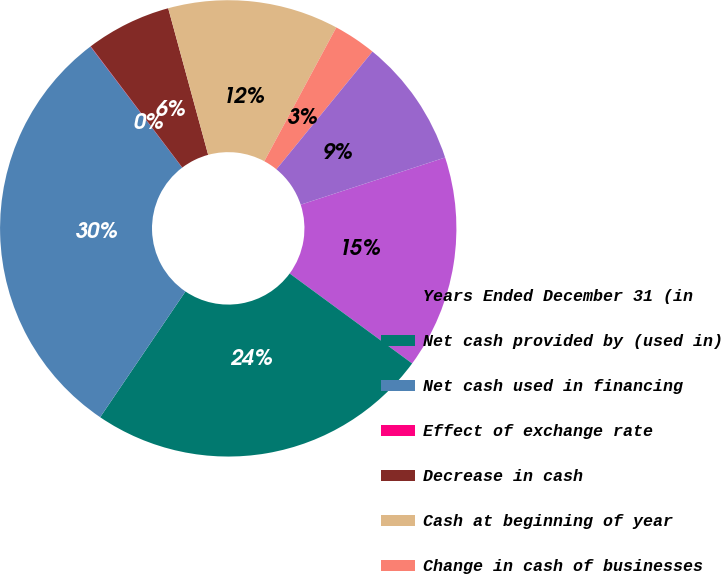Convert chart. <chart><loc_0><loc_0><loc_500><loc_500><pie_chart><fcel>Years Ended December 31 (in<fcel>Net cash provided by (used in)<fcel>Net cash used in financing<fcel>Effect of exchange rate<fcel>Decrease in cash<fcel>Cash at beginning of year<fcel>Change in cash of businesses<fcel>Cash at end of year<nl><fcel>15.11%<fcel>24.4%<fcel>30.2%<fcel>0.02%<fcel>6.06%<fcel>12.09%<fcel>3.04%<fcel>9.08%<nl></chart> 